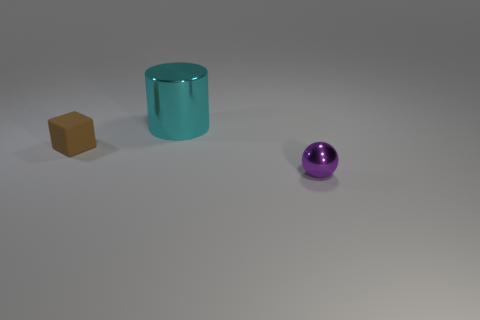There is a shiny thing to the left of the small purple ball that is in front of the cyan cylinder; what color is it?
Give a very brief answer. Cyan. What size is the metallic thing that is behind the small object to the right of the brown object?
Your answer should be compact. Large. How many other things are the same size as the purple metallic sphere?
Offer a terse response. 1. What is the color of the tiny ball that is in front of the metallic object that is on the left side of the tiny thing that is right of the large cyan cylinder?
Make the answer very short. Purple. What number of other things are there of the same shape as the small purple shiny object?
Offer a very short reply. 0. What is the shape of the metal object in front of the tiny brown matte cube?
Offer a terse response. Sphere. Is there a tiny purple ball that is right of the tiny object to the left of the tiny purple ball?
Provide a succinct answer. Yes. The object that is in front of the cylinder and on the right side of the small brown object is what color?
Your answer should be very brief. Purple. Is there a brown rubber block left of the small object to the right of the small thing that is on the left side of the purple shiny object?
Keep it short and to the point. Yes. Are there any other things that are the same material as the tiny block?
Provide a succinct answer. No. 